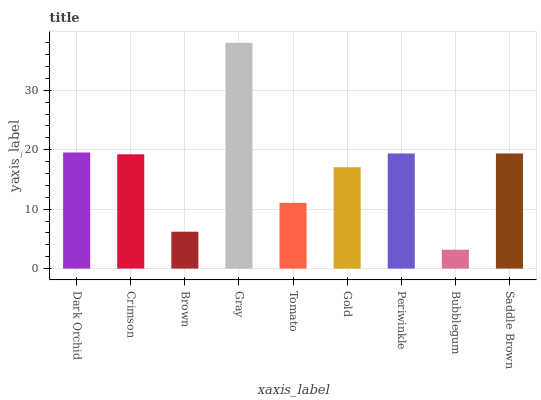Is Bubblegum the minimum?
Answer yes or no. Yes. Is Gray the maximum?
Answer yes or no. Yes. Is Crimson the minimum?
Answer yes or no. No. Is Crimson the maximum?
Answer yes or no. No. Is Dark Orchid greater than Crimson?
Answer yes or no. Yes. Is Crimson less than Dark Orchid?
Answer yes or no. Yes. Is Crimson greater than Dark Orchid?
Answer yes or no. No. Is Dark Orchid less than Crimson?
Answer yes or no. No. Is Crimson the high median?
Answer yes or no. Yes. Is Crimson the low median?
Answer yes or no. Yes. Is Gold the high median?
Answer yes or no. No. Is Bubblegum the low median?
Answer yes or no. No. 